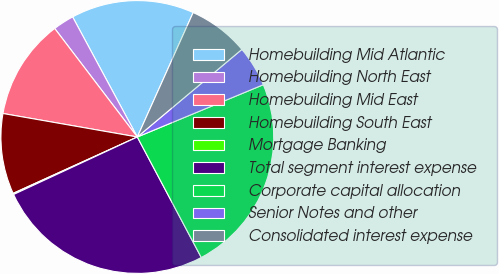<chart> <loc_0><loc_0><loc_500><loc_500><pie_chart><fcel>Homebuilding Mid Atlantic<fcel>Homebuilding North East<fcel>Homebuilding Mid East<fcel>Homebuilding South East<fcel>Mortgage Banking<fcel>Total segment interest expense<fcel>Corporate capital allocation<fcel>Senior Notes and other<fcel>Consolidated interest expense<nl><fcel>14.58%<fcel>2.49%<fcel>11.89%<fcel>9.54%<fcel>0.14%<fcel>25.85%<fcel>23.5%<fcel>4.84%<fcel>7.19%<nl></chart> 